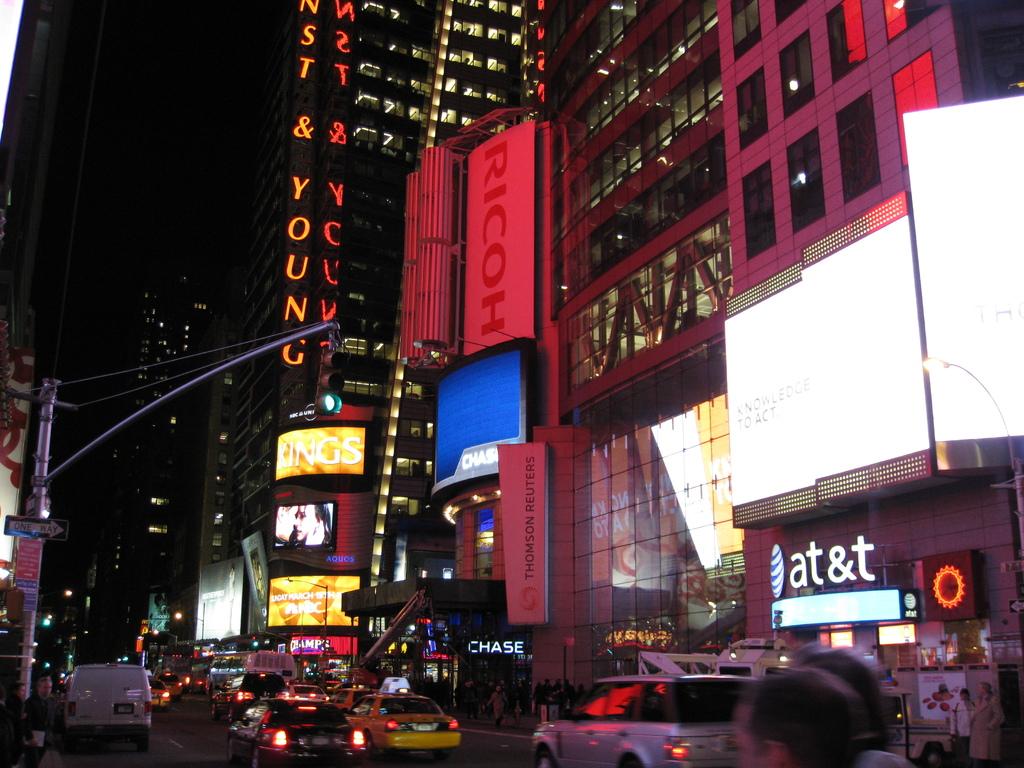What wireless carrier is on the right?
Provide a succinct answer. At&t. What is a word in orange?
Provide a short and direct response. Ricoh. 